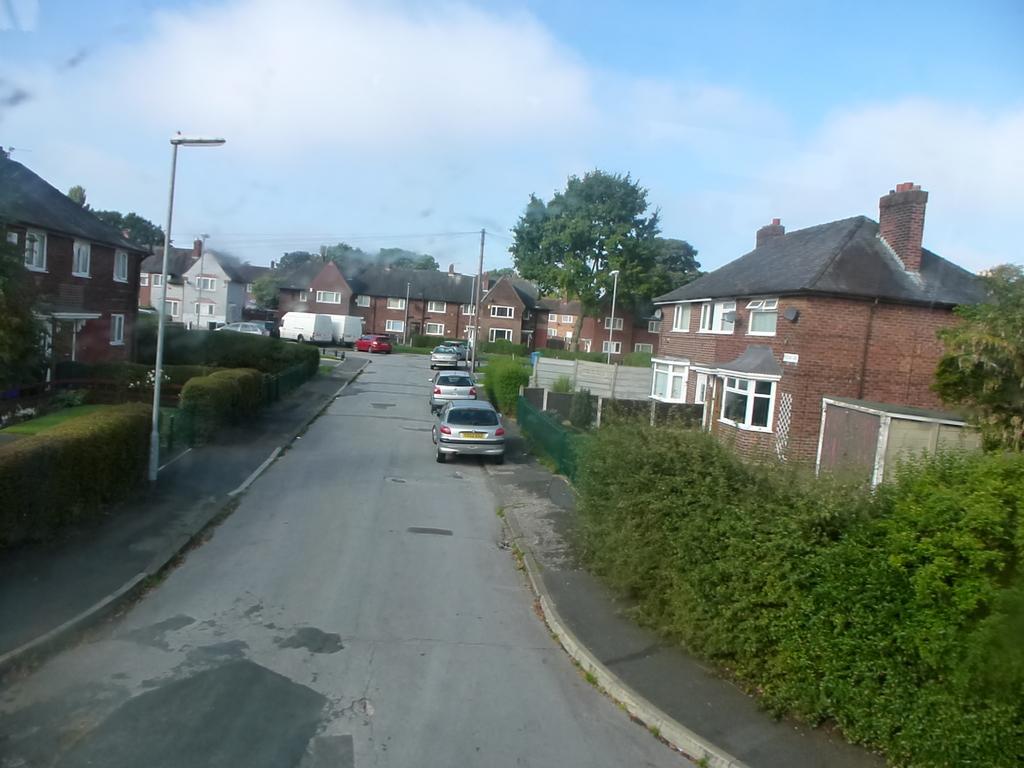Can you describe this image briefly? In this picture I can see buildings, trees, few poles and I can see few cars and vehicles parked and I can see blue cloudy sky. 